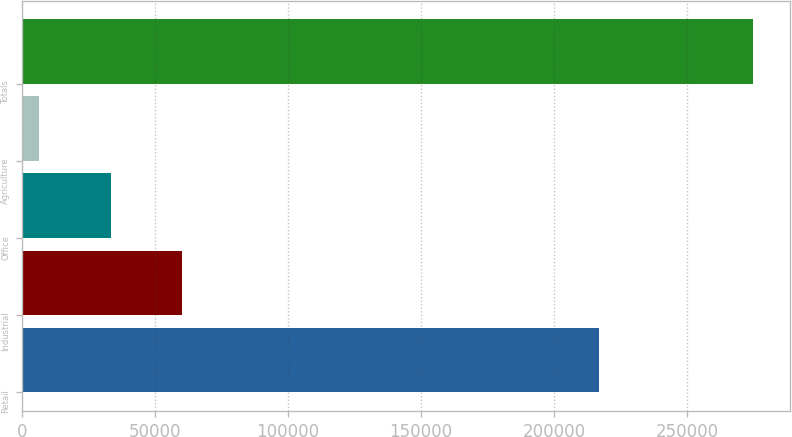Convert chart to OTSL. <chart><loc_0><loc_0><loc_500><loc_500><bar_chart><fcel>Retail<fcel>Industrial<fcel>Office<fcel>Agriculture<fcel>Totals<nl><fcel>216904<fcel>60182.6<fcel>33342.8<fcel>6503<fcel>274901<nl></chart> 